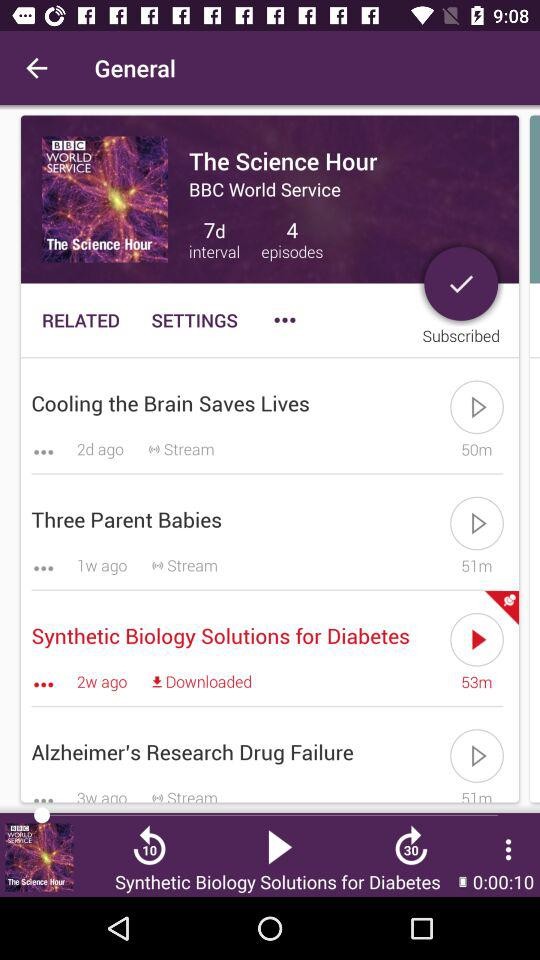How many intervals are there? There are "7d" intervals. 